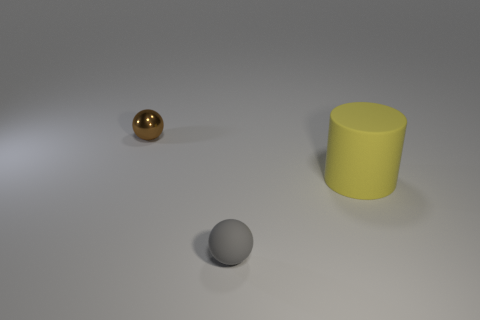Is there any other thing that is the same size as the matte cylinder?
Provide a short and direct response. No. There is a small ball that is in front of the metal thing; what is its color?
Your answer should be compact. Gray. What is the material of the other small thing that is the same shape as the small brown thing?
Your answer should be compact. Rubber. How many matte spheres have the same size as the yellow thing?
Keep it short and to the point. 0. What is the shape of the big yellow matte object?
Offer a terse response. Cylinder. How big is the thing that is both behind the tiny matte sphere and in front of the brown metal sphere?
Provide a succinct answer. Large. What material is the thing to the right of the gray rubber object?
Your answer should be compact. Rubber. What number of things are either matte things that are in front of the big yellow object or rubber objects that are in front of the big cylinder?
Your response must be concise. 1. The thing that is both behind the small gray matte thing and in front of the small brown thing is what color?
Keep it short and to the point. Yellow. Are there more small metal balls than small objects?
Your answer should be very brief. No. 